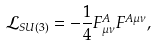Convert formula to latex. <formula><loc_0><loc_0><loc_500><loc_500>\mathcal { L } _ { S U ( 3 ) } = - \frac { 1 } { 4 } F ^ { A } _ { \mu \nu } F ^ { A \mu \nu } ,</formula> 